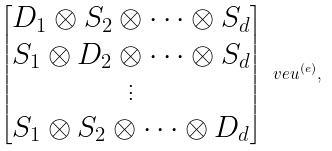<formula> <loc_0><loc_0><loc_500><loc_500>\begin{bmatrix} D _ { 1 } \otimes S _ { 2 } \otimes \dots \otimes S _ { d } \\ S _ { 1 } \otimes D _ { 2 } \otimes \dots \otimes S _ { d } \\ \vdots \\ S _ { 1 } \otimes S _ { 2 } \otimes \dots \otimes D _ { d } \end{bmatrix} \ v e u ^ { ( e ) } ,</formula> 